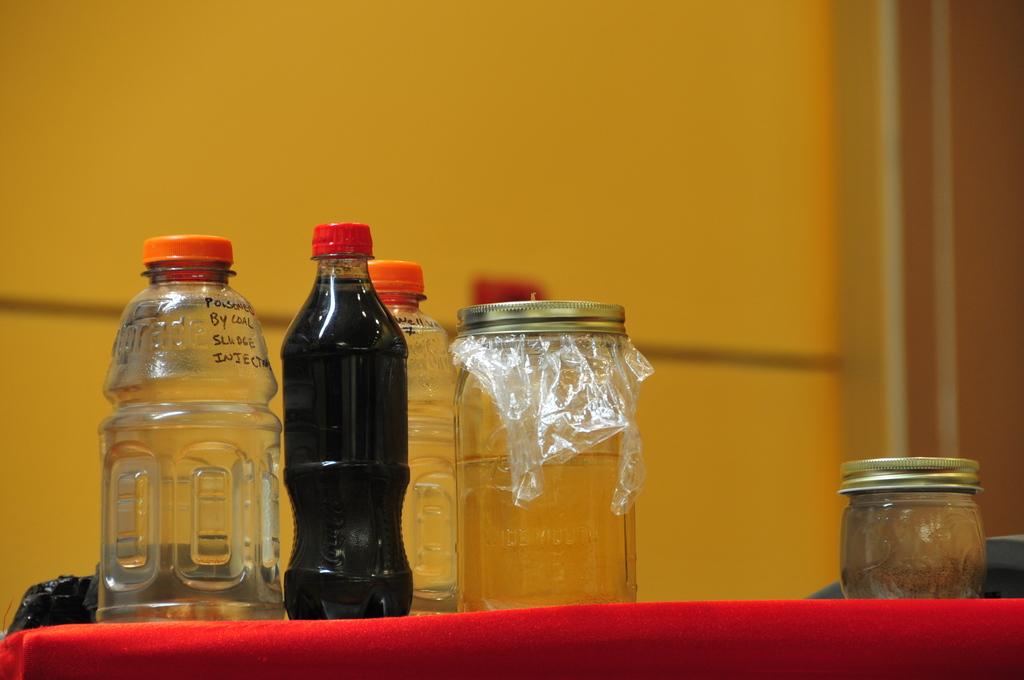What was someone poisoned by, according to the marker writing on the bottle on the left?
Provide a short and direct response. Coal. 